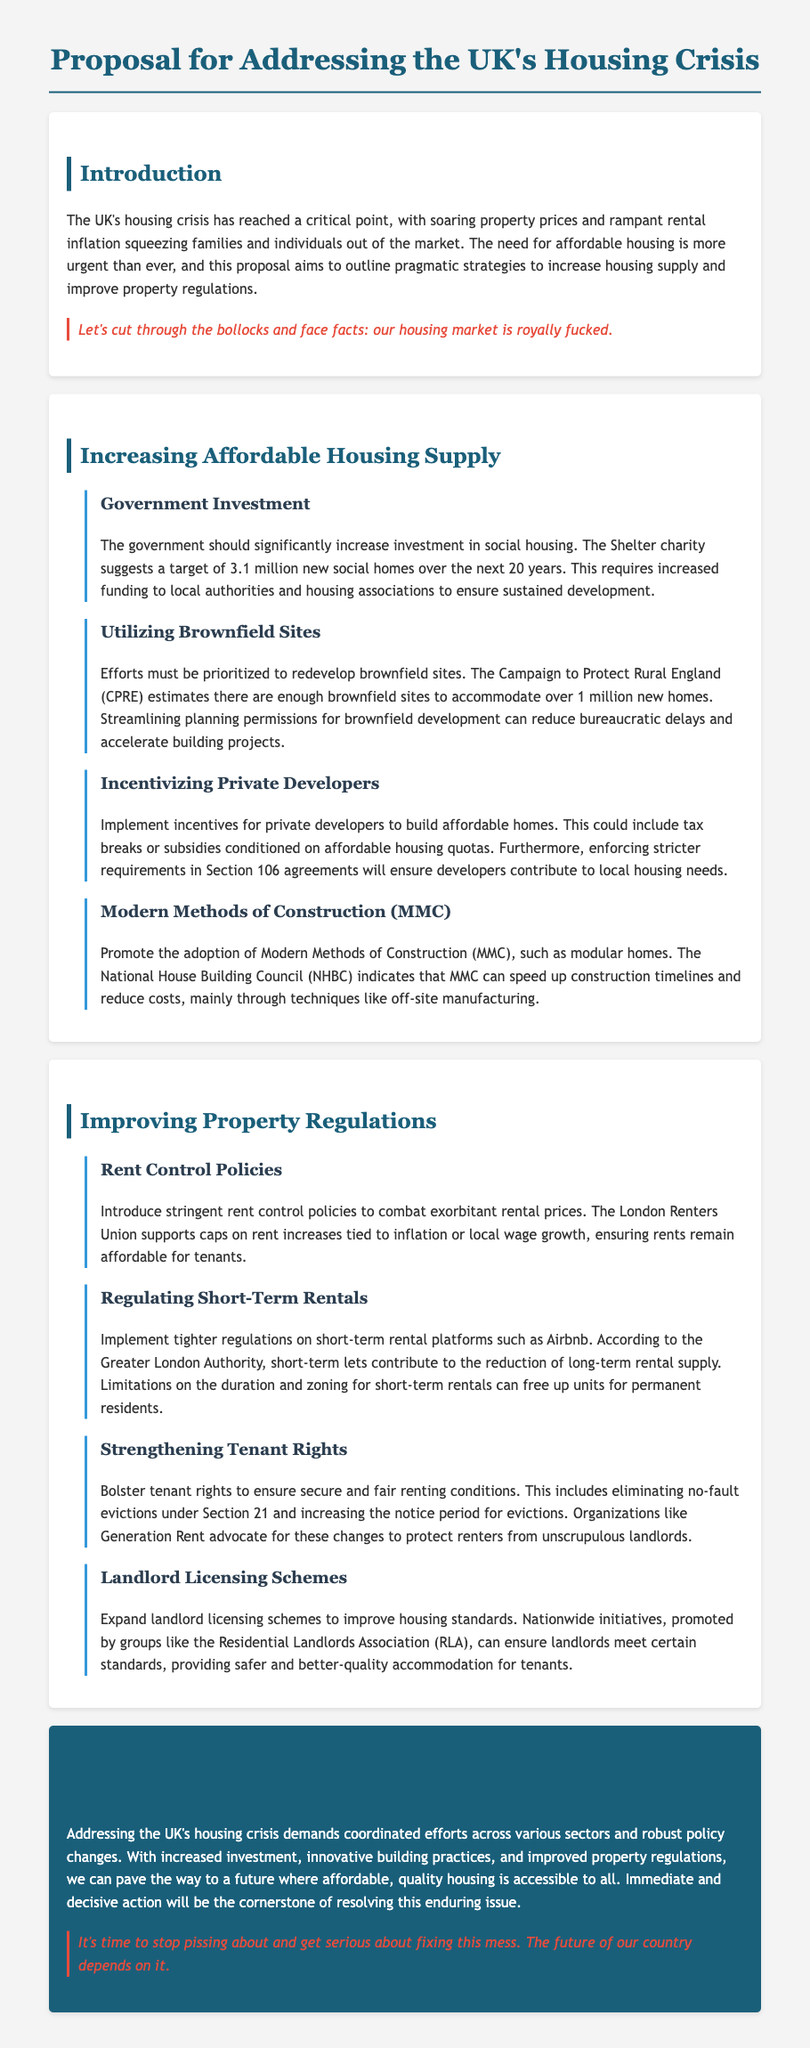What is the target number of new social homes suggested by the Shelter charity? The document states that the Shelter charity suggests a target of 3.1 million new social homes over the next 20 years.
Answer: 3.1 million What is the primary focus for redeveloping brownfield sites? The proposal emphasizes that efforts must be prioritized to redevelop brownfield sites to accommodate over 1 million new homes.
Answer: Over 1 million new homes What type of construction methods does the proposal promote? The proposal promotes the adoption of Modern Methods of Construction (MMC) to speed up construction timelines and reduce costs.
Answer: Modern Methods of Construction (MMC) What do stringent rent control policies aim to address? The document mentions that rent control policies aim to combat exorbitant rental prices.
Answer: Exorbitant rental prices Which organization supports caps on rent increases? The London Renters Union supports caps on rent increases tied to inflation or local wage growth.
Answer: London Renters Union What is one measure to bolster tenant rights mentioned in the proposal? The proposal includes eliminating no-fault evictions under Section 21 as a measure to bolster tenant rights.
Answer: Eliminating no-fault evictions What organization advocates for eliminating no-fault evictions? Generation Rent advocates for changes to protect renters, including eliminating no-fault evictions.
Answer: Generation Rent What is the conclusion's primary call to action? The conclusion emphasizes that immediate and decisive action will be the cornerstone of resolving the housing crisis.
Answer: Immediate and decisive action 